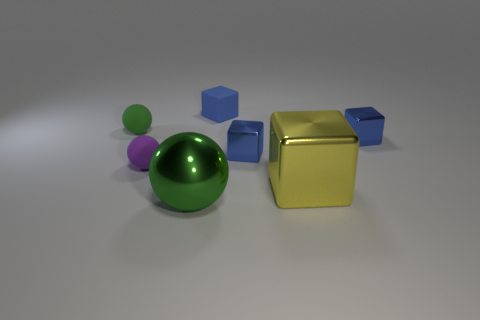Subtract all gray cylinders. How many blue blocks are left? 3 Subtract 1 blocks. How many blocks are left? 3 Add 2 tiny matte objects. How many objects exist? 9 Subtract all spheres. How many objects are left? 4 Subtract all brown cubes. Subtract all rubber balls. How many objects are left? 5 Add 2 green balls. How many green balls are left? 4 Add 6 tiny yellow metal objects. How many tiny yellow metal objects exist? 6 Subtract 0 yellow cylinders. How many objects are left? 7 